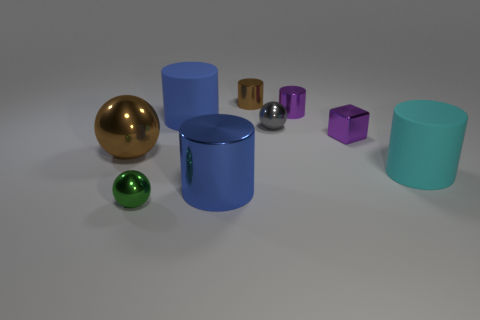How many blue cylinders must be subtracted to get 1 blue cylinders? 1 Subtract all green balls. How many balls are left? 2 Subtract all blocks. How many objects are left? 8 Subtract all brown cylinders. How many cylinders are left? 4 Subtract 0 blue balls. How many objects are left? 9 Subtract 3 cylinders. How many cylinders are left? 2 Subtract all brown spheres. Subtract all gray blocks. How many spheres are left? 2 Subtract all cyan cylinders. How many blue spheres are left? 0 Subtract all brown metal cylinders. Subtract all big blue metallic things. How many objects are left? 7 Add 2 cyan rubber cylinders. How many cyan rubber cylinders are left? 3 